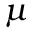Convert formula to latex. <formula><loc_0><loc_0><loc_500><loc_500>\mu</formula> 